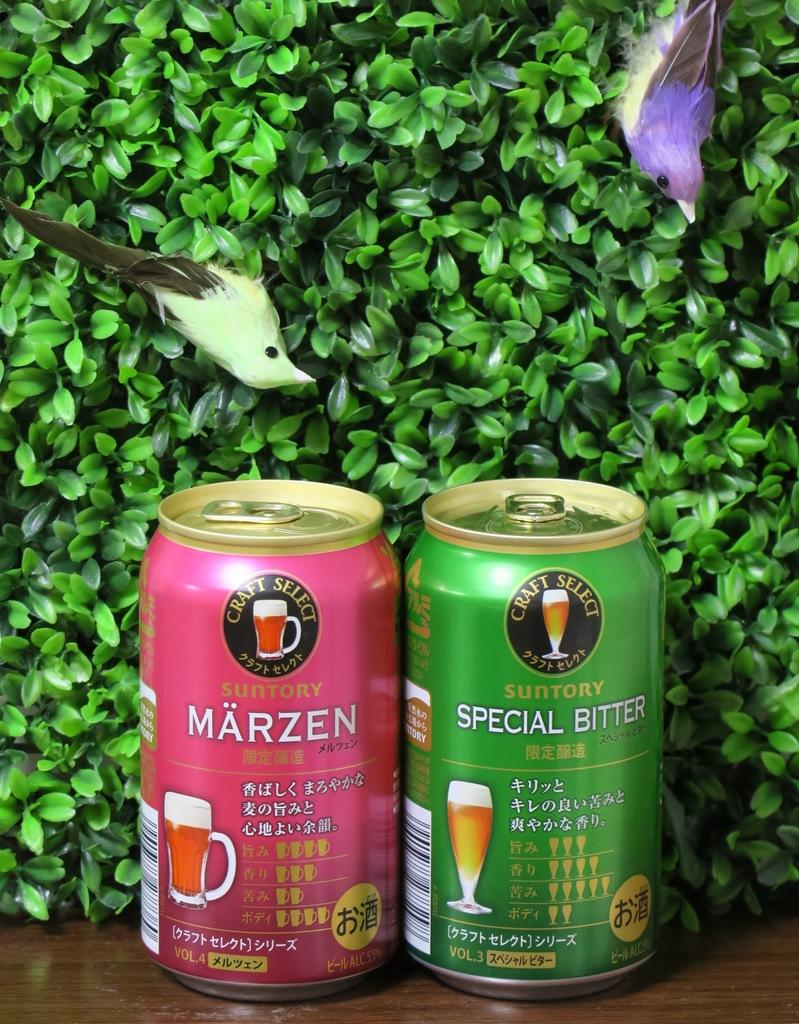<image>
Provide a brief description of the given image. Two fake birds are peering down at cans of beer made by Suntory. 